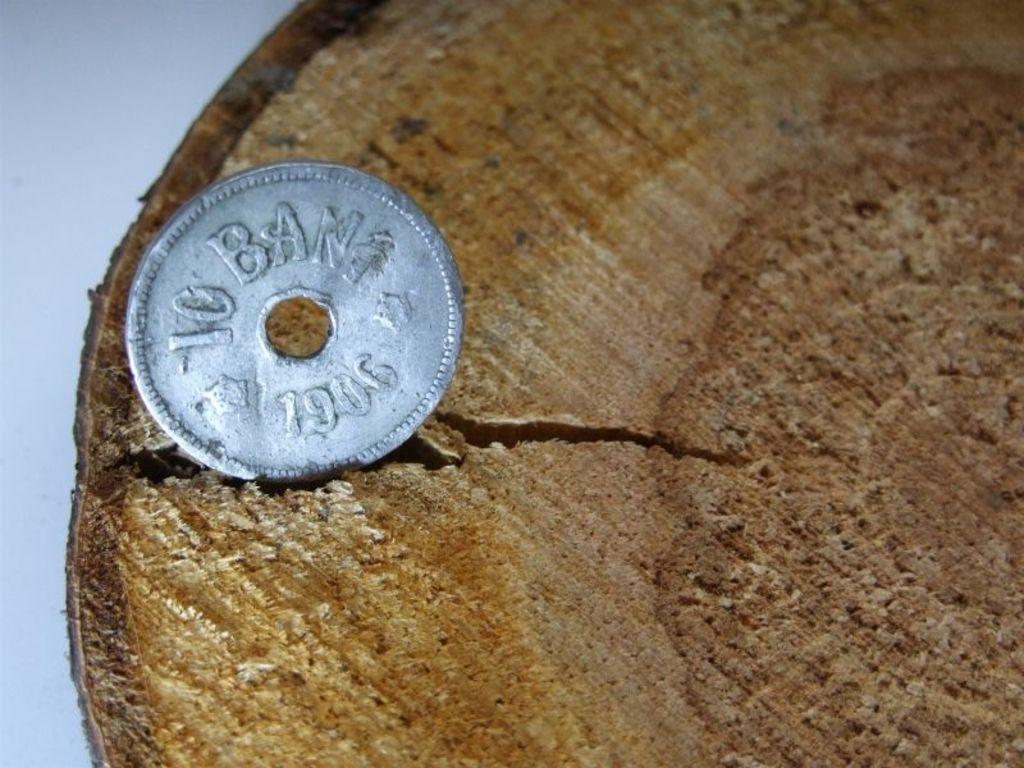<image>
Relay a brief, clear account of the picture shown. a 1906 coin is laying on a piece of weood 